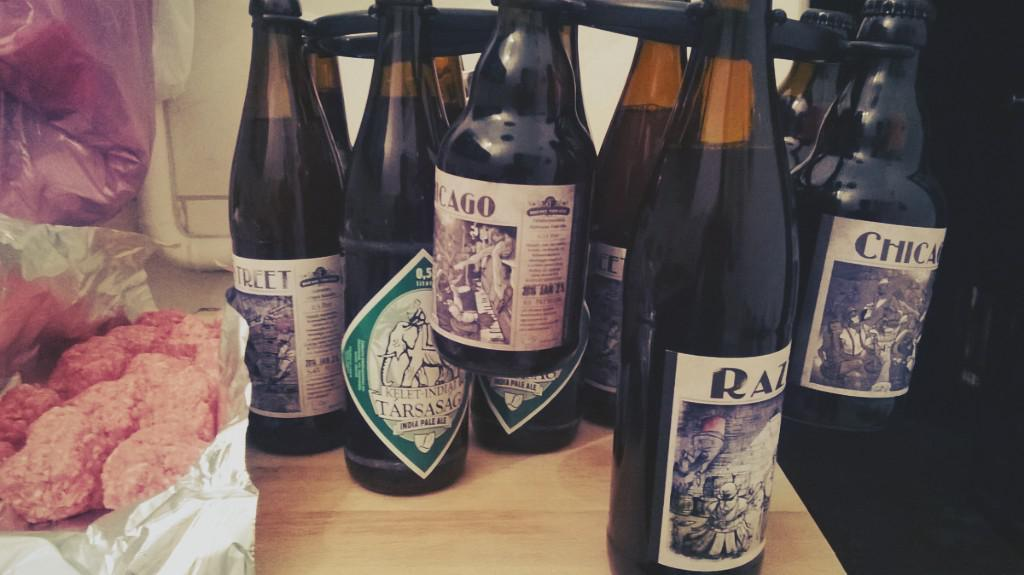What objects are located in the foreground of the image? There are bottles and food placed on a table in the foreground of the image. Can you describe the food on the table? The provided facts do not specify the type of food on the table. What can be seen in the background of the image? There is a wall visible in the background of the image. What type of bear can be seen climbing the wall in the image? There is no bear present in the image; it only features bottles, food on a table, and a wall in the background. 